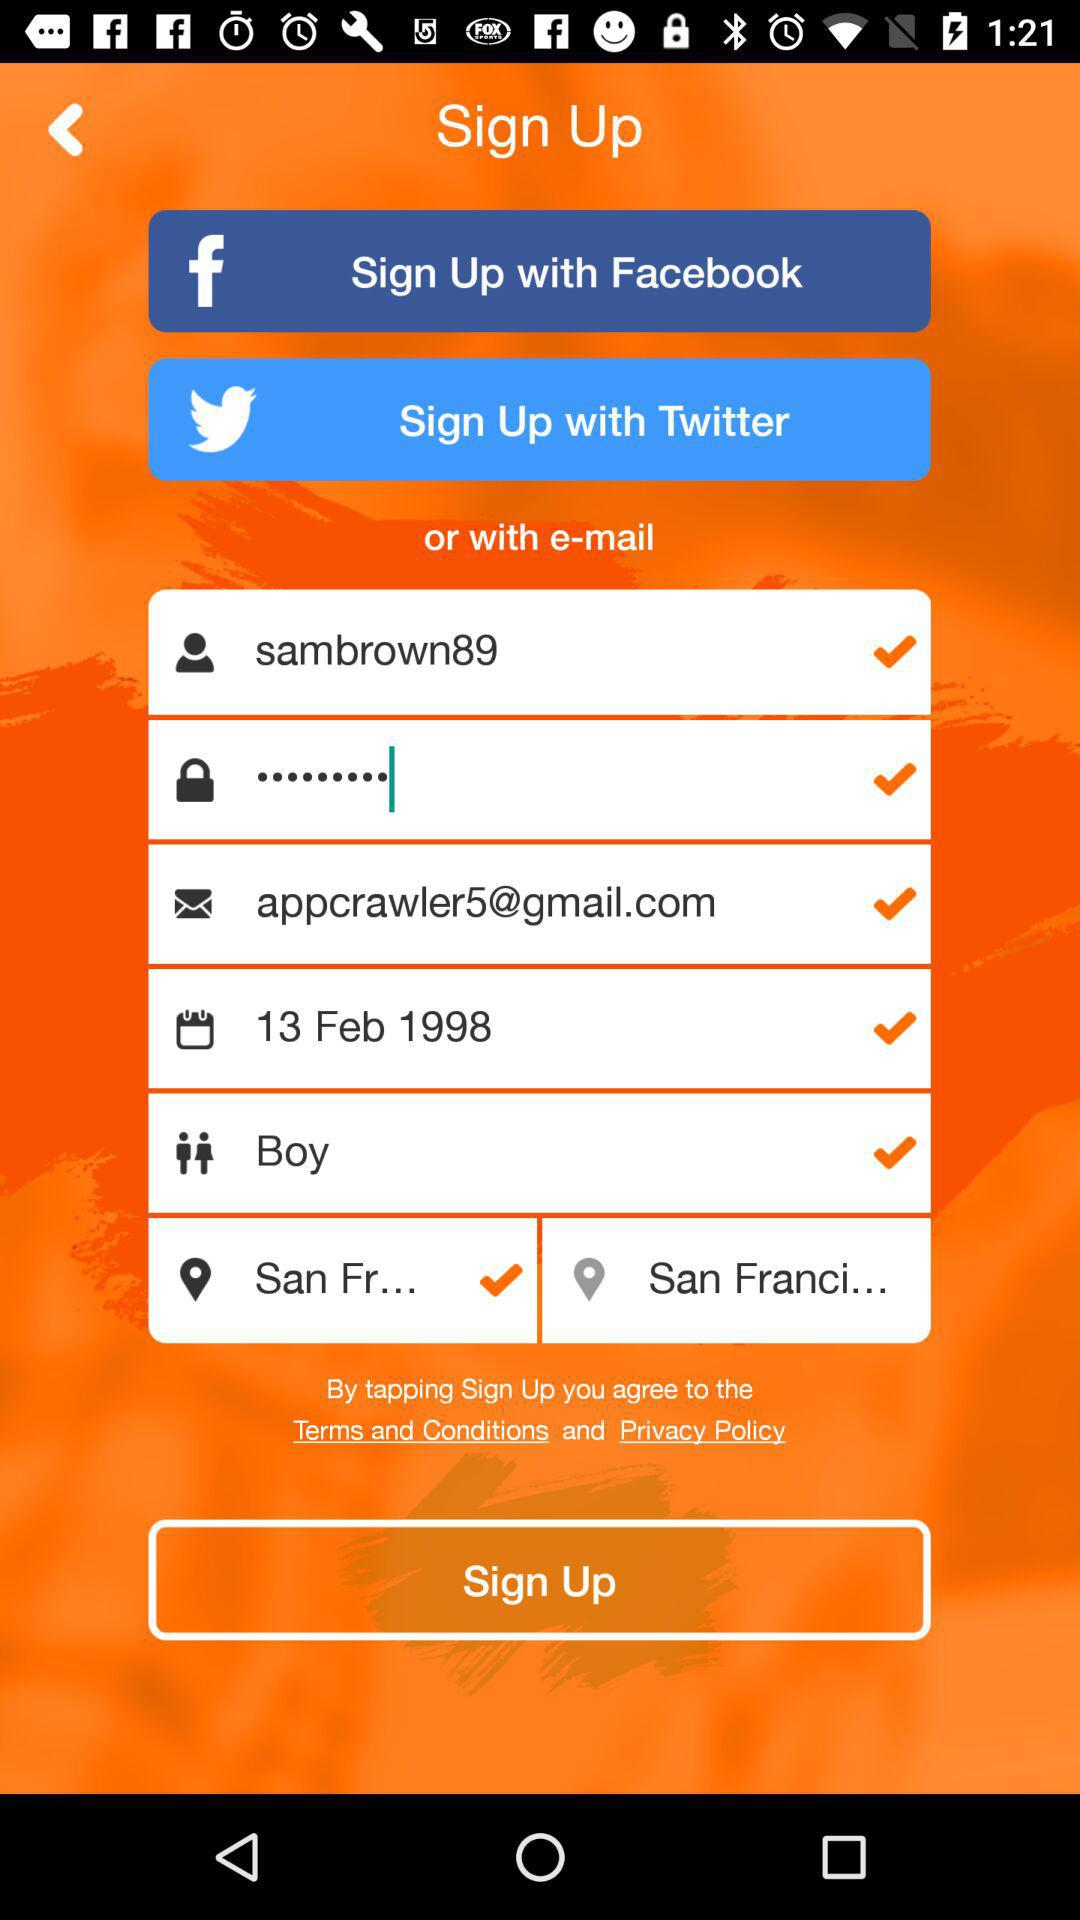What is the date? The date is February 13, 1998. 